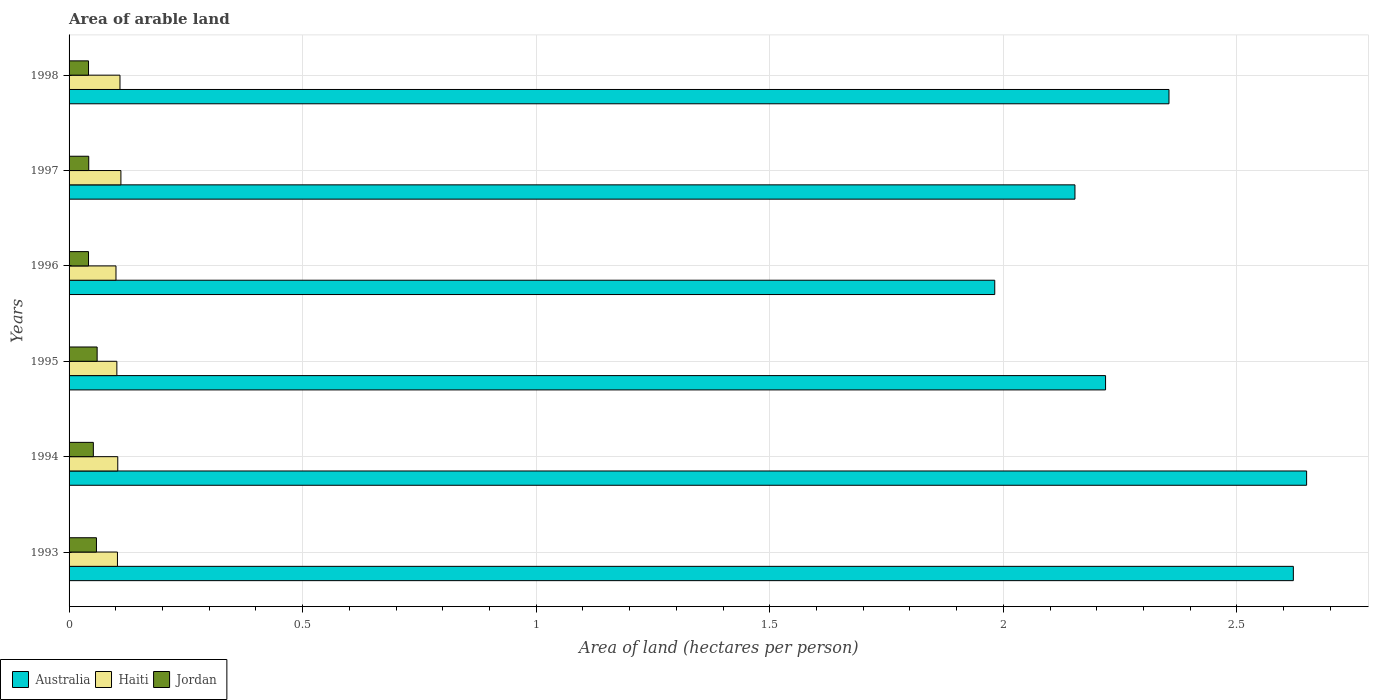Are the number of bars on each tick of the Y-axis equal?
Make the answer very short. Yes. How many bars are there on the 6th tick from the top?
Offer a very short reply. 3. How many bars are there on the 2nd tick from the bottom?
Your answer should be very brief. 3. What is the total arable land in Haiti in 1997?
Offer a terse response. 0.11. Across all years, what is the maximum total arable land in Australia?
Your response must be concise. 2.65. Across all years, what is the minimum total arable land in Haiti?
Offer a very short reply. 0.1. What is the total total arable land in Haiti in the graph?
Give a very brief answer. 0.63. What is the difference between the total arable land in Australia in 1994 and that in 1996?
Provide a succinct answer. 0.67. What is the difference between the total arable land in Australia in 1993 and the total arable land in Haiti in 1996?
Provide a succinct answer. 2.52. What is the average total arable land in Haiti per year?
Your answer should be very brief. 0.11. In the year 1994, what is the difference between the total arable land in Jordan and total arable land in Haiti?
Ensure brevity in your answer.  -0.05. What is the ratio of the total arable land in Haiti in 1993 to that in 1998?
Your response must be concise. 0.95. Is the total arable land in Jordan in 1993 less than that in 1996?
Your answer should be very brief. No. Is the difference between the total arable land in Jordan in 1994 and 1996 greater than the difference between the total arable land in Haiti in 1994 and 1996?
Ensure brevity in your answer.  Yes. What is the difference between the highest and the second highest total arable land in Jordan?
Your response must be concise. 0. What is the difference between the highest and the lowest total arable land in Haiti?
Provide a succinct answer. 0.01. In how many years, is the total arable land in Australia greater than the average total arable land in Australia taken over all years?
Provide a short and direct response. 3. What does the 2nd bar from the top in 1996 represents?
Your answer should be very brief. Haiti. What does the 3rd bar from the bottom in 1994 represents?
Ensure brevity in your answer.  Jordan. Is it the case that in every year, the sum of the total arable land in Australia and total arable land in Jordan is greater than the total arable land in Haiti?
Make the answer very short. Yes. Are all the bars in the graph horizontal?
Provide a succinct answer. Yes. Are the values on the major ticks of X-axis written in scientific E-notation?
Offer a terse response. No. Does the graph contain any zero values?
Offer a terse response. No. Does the graph contain grids?
Ensure brevity in your answer.  Yes. Where does the legend appear in the graph?
Offer a very short reply. Bottom left. How many legend labels are there?
Make the answer very short. 3. What is the title of the graph?
Provide a short and direct response. Area of arable land. Does "Andorra" appear as one of the legend labels in the graph?
Provide a short and direct response. No. What is the label or title of the X-axis?
Give a very brief answer. Area of land (hectares per person). What is the label or title of the Y-axis?
Offer a very short reply. Years. What is the Area of land (hectares per person) of Australia in 1993?
Your response must be concise. 2.62. What is the Area of land (hectares per person) of Haiti in 1993?
Provide a short and direct response. 0.1. What is the Area of land (hectares per person) of Jordan in 1993?
Provide a short and direct response. 0.06. What is the Area of land (hectares per person) in Australia in 1994?
Your response must be concise. 2.65. What is the Area of land (hectares per person) in Haiti in 1994?
Keep it short and to the point. 0.1. What is the Area of land (hectares per person) in Jordan in 1994?
Keep it short and to the point. 0.05. What is the Area of land (hectares per person) of Australia in 1995?
Your response must be concise. 2.22. What is the Area of land (hectares per person) in Haiti in 1995?
Make the answer very short. 0.1. What is the Area of land (hectares per person) in Jordan in 1995?
Offer a terse response. 0.06. What is the Area of land (hectares per person) in Australia in 1996?
Give a very brief answer. 1.98. What is the Area of land (hectares per person) of Haiti in 1996?
Your answer should be compact. 0.1. What is the Area of land (hectares per person) of Jordan in 1996?
Keep it short and to the point. 0.04. What is the Area of land (hectares per person) in Australia in 1997?
Make the answer very short. 2.15. What is the Area of land (hectares per person) in Haiti in 1997?
Keep it short and to the point. 0.11. What is the Area of land (hectares per person) in Jordan in 1997?
Keep it short and to the point. 0.04. What is the Area of land (hectares per person) of Australia in 1998?
Provide a succinct answer. 2.35. What is the Area of land (hectares per person) of Haiti in 1998?
Give a very brief answer. 0.11. What is the Area of land (hectares per person) in Jordan in 1998?
Provide a short and direct response. 0.04. Across all years, what is the maximum Area of land (hectares per person) of Australia?
Offer a terse response. 2.65. Across all years, what is the maximum Area of land (hectares per person) in Haiti?
Your response must be concise. 0.11. Across all years, what is the maximum Area of land (hectares per person) in Jordan?
Your answer should be compact. 0.06. Across all years, what is the minimum Area of land (hectares per person) in Australia?
Offer a very short reply. 1.98. Across all years, what is the minimum Area of land (hectares per person) in Haiti?
Keep it short and to the point. 0.1. Across all years, what is the minimum Area of land (hectares per person) in Jordan?
Keep it short and to the point. 0.04. What is the total Area of land (hectares per person) in Australia in the graph?
Provide a short and direct response. 13.98. What is the total Area of land (hectares per person) in Haiti in the graph?
Keep it short and to the point. 0.63. What is the total Area of land (hectares per person) of Jordan in the graph?
Keep it short and to the point. 0.3. What is the difference between the Area of land (hectares per person) in Australia in 1993 and that in 1994?
Your answer should be compact. -0.03. What is the difference between the Area of land (hectares per person) of Haiti in 1993 and that in 1994?
Provide a succinct answer. -0. What is the difference between the Area of land (hectares per person) in Jordan in 1993 and that in 1994?
Your response must be concise. 0.01. What is the difference between the Area of land (hectares per person) of Australia in 1993 and that in 1995?
Offer a very short reply. 0.4. What is the difference between the Area of land (hectares per person) of Haiti in 1993 and that in 1995?
Your answer should be compact. 0. What is the difference between the Area of land (hectares per person) in Jordan in 1993 and that in 1995?
Provide a succinct answer. -0. What is the difference between the Area of land (hectares per person) in Australia in 1993 and that in 1996?
Your answer should be compact. 0.64. What is the difference between the Area of land (hectares per person) of Haiti in 1993 and that in 1996?
Your response must be concise. 0. What is the difference between the Area of land (hectares per person) of Jordan in 1993 and that in 1996?
Provide a short and direct response. 0.02. What is the difference between the Area of land (hectares per person) in Australia in 1993 and that in 1997?
Offer a terse response. 0.47. What is the difference between the Area of land (hectares per person) in Haiti in 1993 and that in 1997?
Offer a very short reply. -0.01. What is the difference between the Area of land (hectares per person) in Jordan in 1993 and that in 1997?
Your answer should be compact. 0.02. What is the difference between the Area of land (hectares per person) of Australia in 1993 and that in 1998?
Your answer should be very brief. 0.27. What is the difference between the Area of land (hectares per person) in Haiti in 1993 and that in 1998?
Your answer should be compact. -0.01. What is the difference between the Area of land (hectares per person) of Jordan in 1993 and that in 1998?
Your response must be concise. 0.02. What is the difference between the Area of land (hectares per person) of Australia in 1994 and that in 1995?
Offer a very short reply. 0.43. What is the difference between the Area of land (hectares per person) of Haiti in 1994 and that in 1995?
Ensure brevity in your answer.  0. What is the difference between the Area of land (hectares per person) of Jordan in 1994 and that in 1995?
Your answer should be very brief. -0.01. What is the difference between the Area of land (hectares per person) of Australia in 1994 and that in 1996?
Provide a succinct answer. 0.67. What is the difference between the Area of land (hectares per person) in Haiti in 1994 and that in 1996?
Make the answer very short. 0. What is the difference between the Area of land (hectares per person) of Jordan in 1994 and that in 1996?
Ensure brevity in your answer.  0.01. What is the difference between the Area of land (hectares per person) in Australia in 1994 and that in 1997?
Provide a short and direct response. 0.5. What is the difference between the Area of land (hectares per person) of Haiti in 1994 and that in 1997?
Provide a short and direct response. -0.01. What is the difference between the Area of land (hectares per person) of Jordan in 1994 and that in 1997?
Your response must be concise. 0.01. What is the difference between the Area of land (hectares per person) in Australia in 1994 and that in 1998?
Provide a short and direct response. 0.29. What is the difference between the Area of land (hectares per person) of Haiti in 1994 and that in 1998?
Your answer should be very brief. -0. What is the difference between the Area of land (hectares per person) of Jordan in 1994 and that in 1998?
Give a very brief answer. 0.01. What is the difference between the Area of land (hectares per person) in Australia in 1995 and that in 1996?
Give a very brief answer. 0.24. What is the difference between the Area of land (hectares per person) in Haiti in 1995 and that in 1996?
Ensure brevity in your answer.  0. What is the difference between the Area of land (hectares per person) in Jordan in 1995 and that in 1996?
Provide a succinct answer. 0.02. What is the difference between the Area of land (hectares per person) in Australia in 1995 and that in 1997?
Give a very brief answer. 0.07. What is the difference between the Area of land (hectares per person) of Haiti in 1995 and that in 1997?
Provide a short and direct response. -0.01. What is the difference between the Area of land (hectares per person) of Jordan in 1995 and that in 1997?
Offer a very short reply. 0.02. What is the difference between the Area of land (hectares per person) of Australia in 1995 and that in 1998?
Give a very brief answer. -0.14. What is the difference between the Area of land (hectares per person) of Haiti in 1995 and that in 1998?
Offer a terse response. -0.01. What is the difference between the Area of land (hectares per person) in Jordan in 1995 and that in 1998?
Make the answer very short. 0.02. What is the difference between the Area of land (hectares per person) in Australia in 1996 and that in 1997?
Make the answer very short. -0.17. What is the difference between the Area of land (hectares per person) in Haiti in 1996 and that in 1997?
Your answer should be very brief. -0.01. What is the difference between the Area of land (hectares per person) in Jordan in 1996 and that in 1997?
Provide a succinct answer. -0. What is the difference between the Area of land (hectares per person) in Australia in 1996 and that in 1998?
Provide a succinct answer. -0.37. What is the difference between the Area of land (hectares per person) of Haiti in 1996 and that in 1998?
Offer a very short reply. -0.01. What is the difference between the Area of land (hectares per person) in Australia in 1997 and that in 1998?
Your answer should be very brief. -0.2. What is the difference between the Area of land (hectares per person) of Haiti in 1997 and that in 1998?
Your answer should be compact. 0. What is the difference between the Area of land (hectares per person) in Jordan in 1997 and that in 1998?
Keep it short and to the point. 0. What is the difference between the Area of land (hectares per person) in Australia in 1993 and the Area of land (hectares per person) in Haiti in 1994?
Give a very brief answer. 2.52. What is the difference between the Area of land (hectares per person) in Australia in 1993 and the Area of land (hectares per person) in Jordan in 1994?
Your answer should be compact. 2.57. What is the difference between the Area of land (hectares per person) of Haiti in 1993 and the Area of land (hectares per person) of Jordan in 1994?
Offer a very short reply. 0.05. What is the difference between the Area of land (hectares per person) of Australia in 1993 and the Area of land (hectares per person) of Haiti in 1995?
Provide a short and direct response. 2.52. What is the difference between the Area of land (hectares per person) of Australia in 1993 and the Area of land (hectares per person) of Jordan in 1995?
Make the answer very short. 2.56. What is the difference between the Area of land (hectares per person) of Haiti in 1993 and the Area of land (hectares per person) of Jordan in 1995?
Ensure brevity in your answer.  0.04. What is the difference between the Area of land (hectares per person) of Australia in 1993 and the Area of land (hectares per person) of Haiti in 1996?
Keep it short and to the point. 2.52. What is the difference between the Area of land (hectares per person) of Australia in 1993 and the Area of land (hectares per person) of Jordan in 1996?
Offer a very short reply. 2.58. What is the difference between the Area of land (hectares per person) in Haiti in 1993 and the Area of land (hectares per person) in Jordan in 1996?
Offer a terse response. 0.06. What is the difference between the Area of land (hectares per person) in Australia in 1993 and the Area of land (hectares per person) in Haiti in 1997?
Make the answer very short. 2.51. What is the difference between the Area of land (hectares per person) in Australia in 1993 and the Area of land (hectares per person) in Jordan in 1997?
Your response must be concise. 2.58. What is the difference between the Area of land (hectares per person) of Haiti in 1993 and the Area of land (hectares per person) of Jordan in 1997?
Offer a terse response. 0.06. What is the difference between the Area of land (hectares per person) of Australia in 1993 and the Area of land (hectares per person) of Haiti in 1998?
Your answer should be compact. 2.51. What is the difference between the Area of land (hectares per person) of Australia in 1993 and the Area of land (hectares per person) of Jordan in 1998?
Offer a very short reply. 2.58. What is the difference between the Area of land (hectares per person) in Haiti in 1993 and the Area of land (hectares per person) in Jordan in 1998?
Keep it short and to the point. 0.06. What is the difference between the Area of land (hectares per person) in Australia in 1994 and the Area of land (hectares per person) in Haiti in 1995?
Ensure brevity in your answer.  2.55. What is the difference between the Area of land (hectares per person) of Australia in 1994 and the Area of land (hectares per person) of Jordan in 1995?
Your response must be concise. 2.59. What is the difference between the Area of land (hectares per person) of Haiti in 1994 and the Area of land (hectares per person) of Jordan in 1995?
Provide a succinct answer. 0.04. What is the difference between the Area of land (hectares per person) in Australia in 1994 and the Area of land (hectares per person) in Haiti in 1996?
Ensure brevity in your answer.  2.55. What is the difference between the Area of land (hectares per person) of Australia in 1994 and the Area of land (hectares per person) of Jordan in 1996?
Make the answer very short. 2.61. What is the difference between the Area of land (hectares per person) in Haiti in 1994 and the Area of land (hectares per person) in Jordan in 1996?
Ensure brevity in your answer.  0.06. What is the difference between the Area of land (hectares per person) in Australia in 1994 and the Area of land (hectares per person) in Haiti in 1997?
Your response must be concise. 2.54. What is the difference between the Area of land (hectares per person) in Australia in 1994 and the Area of land (hectares per person) in Jordan in 1997?
Ensure brevity in your answer.  2.61. What is the difference between the Area of land (hectares per person) in Haiti in 1994 and the Area of land (hectares per person) in Jordan in 1997?
Give a very brief answer. 0.06. What is the difference between the Area of land (hectares per person) in Australia in 1994 and the Area of land (hectares per person) in Haiti in 1998?
Your answer should be compact. 2.54. What is the difference between the Area of land (hectares per person) in Australia in 1994 and the Area of land (hectares per person) in Jordan in 1998?
Make the answer very short. 2.61. What is the difference between the Area of land (hectares per person) in Haiti in 1994 and the Area of land (hectares per person) in Jordan in 1998?
Provide a short and direct response. 0.06. What is the difference between the Area of land (hectares per person) in Australia in 1995 and the Area of land (hectares per person) in Haiti in 1996?
Keep it short and to the point. 2.12. What is the difference between the Area of land (hectares per person) of Australia in 1995 and the Area of land (hectares per person) of Jordan in 1996?
Your response must be concise. 2.18. What is the difference between the Area of land (hectares per person) of Haiti in 1995 and the Area of land (hectares per person) of Jordan in 1996?
Your answer should be compact. 0.06. What is the difference between the Area of land (hectares per person) in Australia in 1995 and the Area of land (hectares per person) in Haiti in 1997?
Your response must be concise. 2.11. What is the difference between the Area of land (hectares per person) in Australia in 1995 and the Area of land (hectares per person) in Jordan in 1997?
Provide a succinct answer. 2.18. What is the difference between the Area of land (hectares per person) in Haiti in 1995 and the Area of land (hectares per person) in Jordan in 1997?
Make the answer very short. 0.06. What is the difference between the Area of land (hectares per person) of Australia in 1995 and the Area of land (hectares per person) of Haiti in 1998?
Offer a very short reply. 2.11. What is the difference between the Area of land (hectares per person) in Australia in 1995 and the Area of land (hectares per person) in Jordan in 1998?
Provide a short and direct response. 2.18. What is the difference between the Area of land (hectares per person) in Haiti in 1995 and the Area of land (hectares per person) in Jordan in 1998?
Offer a very short reply. 0.06. What is the difference between the Area of land (hectares per person) in Australia in 1996 and the Area of land (hectares per person) in Haiti in 1997?
Ensure brevity in your answer.  1.87. What is the difference between the Area of land (hectares per person) of Australia in 1996 and the Area of land (hectares per person) of Jordan in 1997?
Make the answer very short. 1.94. What is the difference between the Area of land (hectares per person) in Haiti in 1996 and the Area of land (hectares per person) in Jordan in 1997?
Provide a succinct answer. 0.06. What is the difference between the Area of land (hectares per person) in Australia in 1996 and the Area of land (hectares per person) in Haiti in 1998?
Give a very brief answer. 1.87. What is the difference between the Area of land (hectares per person) of Australia in 1996 and the Area of land (hectares per person) of Jordan in 1998?
Provide a succinct answer. 1.94. What is the difference between the Area of land (hectares per person) of Haiti in 1996 and the Area of land (hectares per person) of Jordan in 1998?
Keep it short and to the point. 0.06. What is the difference between the Area of land (hectares per person) of Australia in 1997 and the Area of land (hectares per person) of Haiti in 1998?
Offer a very short reply. 2.04. What is the difference between the Area of land (hectares per person) in Australia in 1997 and the Area of land (hectares per person) in Jordan in 1998?
Your response must be concise. 2.11. What is the difference between the Area of land (hectares per person) in Haiti in 1997 and the Area of land (hectares per person) in Jordan in 1998?
Provide a succinct answer. 0.07. What is the average Area of land (hectares per person) in Australia per year?
Make the answer very short. 2.33. What is the average Area of land (hectares per person) in Haiti per year?
Your response must be concise. 0.11. What is the average Area of land (hectares per person) of Jordan per year?
Give a very brief answer. 0.05. In the year 1993, what is the difference between the Area of land (hectares per person) in Australia and Area of land (hectares per person) in Haiti?
Give a very brief answer. 2.52. In the year 1993, what is the difference between the Area of land (hectares per person) in Australia and Area of land (hectares per person) in Jordan?
Offer a very short reply. 2.56. In the year 1993, what is the difference between the Area of land (hectares per person) of Haiti and Area of land (hectares per person) of Jordan?
Your answer should be compact. 0.04. In the year 1994, what is the difference between the Area of land (hectares per person) of Australia and Area of land (hectares per person) of Haiti?
Your response must be concise. 2.54. In the year 1994, what is the difference between the Area of land (hectares per person) in Australia and Area of land (hectares per person) in Jordan?
Your response must be concise. 2.6. In the year 1994, what is the difference between the Area of land (hectares per person) of Haiti and Area of land (hectares per person) of Jordan?
Provide a short and direct response. 0.05. In the year 1995, what is the difference between the Area of land (hectares per person) in Australia and Area of land (hectares per person) in Haiti?
Provide a short and direct response. 2.12. In the year 1995, what is the difference between the Area of land (hectares per person) of Australia and Area of land (hectares per person) of Jordan?
Provide a succinct answer. 2.16. In the year 1995, what is the difference between the Area of land (hectares per person) of Haiti and Area of land (hectares per person) of Jordan?
Your answer should be very brief. 0.04. In the year 1996, what is the difference between the Area of land (hectares per person) in Australia and Area of land (hectares per person) in Haiti?
Your response must be concise. 1.88. In the year 1996, what is the difference between the Area of land (hectares per person) in Australia and Area of land (hectares per person) in Jordan?
Give a very brief answer. 1.94. In the year 1996, what is the difference between the Area of land (hectares per person) in Haiti and Area of land (hectares per person) in Jordan?
Your answer should be very brief. 0.06. In the year 1997, what is the difference between the Area of land (hectares per person) of Australia and Area of land (hectares per person) of Haiti?
Your answer should be very brief. 2.04. In the year 1997, what is the difference between the Area of land (hectares per person) in Australia and Area of land (hectares per person) in Jordan?
Provide a short and direct response. 2.11. In the year 1997, what is the difference between the Area of land (hectares per person) in Haiti and Area of land (hectares per person) in Jordan?
Make the answer very short. 0.07. In the year 1998, what is the difference between the Area of land (hectares per person) in Australia and Area of land (hectares per person) in Haiti?
Offer a terse response. 2.25. In the year 1998, what is the difference between the Area of land (hectares per person) of Australia and Area of land (hectares per person) of Jordan?
Make the answer very short. 2.31. In the year 1998, what is the difference between the Area of land (hectares per person) of Haiti and Area of land (hectares per person) of Jordan?
Ensure brevity in your answer.  0.07. What is the ratio of the Area of land (hectares per person) of Australia in 1993 to that in 1994?
Make the answer very short. 0.99. What is the ratio of the Area of land (hectares per person) in Jordan in 1993 to that in 1994?
Provide a succinct answer. 1.13. What is the ratio of the Area of land (hectares per person) in Australia in 1993 to that in 1995?
Keep it short and to the point. 1.18. What is the ratio of the Area of land (hectares per person) of Haiti in 1993 to that in 1995?
Offer a very short reply. 1.01. What is the ratio of the Area of land (hectares per person) of Jordan in 1993 to that in 1995?
Offer a terse response. 0.98. What is the ratio of the Area of land (hectares per person) in Australia in 1993 to that in 1996?
Your response must be concise. 1.32. What is the ratio of the Area of land (hectares per person) in Haiti in 1993 to that in 1996?
Provide a succinct answer. 1.03. What is the ratio of the Area of land (hectares per person) of Jordan in 1993 to that in 1996?
Offer a terse response. 1.41. What is the ratio of the Area of land (hectares per person) in Australia in 1993 to that in 1997?
Keep it short and to the point. 1.22. What is the ratio of the Area of land (hectares per person) in Haiti in 1993 to that in 1997?
Provide a succinct answer. 0.93. What is the ratio of the Area of land (hectares per person) of Jordan in 1993 to that in 1997?
Offer a very short reply. 1.39. What is the ratio of the Area of land (hectares per person) of Australia in 1993 to that in 1998?
Keep it short and to the point. 1.11. What is the ratio of the Area of land (hectares per person) in Haiti in 1993 to that in 1998?
Make the answer very short. 0.95. What is the ratio of the Area of land (hectares per person) in Jordan in 1993 to that in 1998?
Offer a terse response. 1.41. What is the ratio of the Area of land (hectares per person) in Australia in 1994 to that in 1995?
Give a very brief answer. 1.19. What is the ratio of the Area of land (hectares per person) of Haiti in 1994 to that in 1995?
Make the answer very short. 1.02. What is the ratio of the Area of land (hectares per person) in Jordan in 1994 to that in 1995?
Your answer should be compact. 0.86. What is the ratio of the Area of land (hectares per person) of Australia in 1994 to that in 1996?
Offer a terse response. 1.34. What is the ratio of the Area of land (hectares per person) in Haiti in 1994 to that in 1996?
Offer a very short reply. 1.04. What is the ratio of the Area of land (hectares per person) of Jordan in 1994 to that in 1996?
Offer a very short reply. 1.25. What is the ratio of the Area of land (hectares per person) of Australia in 1994 to that in 1997?
Ensure brevity in your answer.  1.23. What is the ratio of the Area of land (hectares per person) of Haiti in 1994 to that in 1997?
Your answer should be very brief. 0.94. What is the ratio of the Area of land (hectares per person) of Jordan in 1994 to that in 1997?
Your response must be concise. 1.23. What is the ratio of the Area of land (hectares per person) of Australia in 1994 to that in 1998?
Offer a very short reply. 1.13. What is the ratio of the Area of land (hectares per person) of Haiti in 1994 to that in 1998?
Offer a very short reply. 0.96. What is the ratio of the Area of land (hectares per person) in Jordan in 1994 to that in 1998?
Keep it short and to the point. 1.25. What is the ratio of the Area of land (hectares per person) of Australia in 1995 to that in 1996?
Offer a very short reply. 1.12. What is the ratio of the Area of land (hectares per person) of Haiti in 1995 to that in 1996?
Keep it short and to the point. 1.02. What is the ratio of the Area of land (hectares per person) in Jordan in 1995 to that in 1996?
Provide a short and direct response. 1.44. What is the ratio of the Area of land (hectares per person) of Australia in 1995 to that in 1997?
Your answer should be compact. 1.03. What is the ratio of the Area of land (hectares per person) in Haiti in 1995 to that in 1997?
Your response must be concise. 0.92. What is the ratio of the Area of land (hectares per person) in Jordan in 1995 to that in 1997?
Your response must be concise. 1.43. What is the ratio of the Area of land (hectares per person) of Australia in 1995 to that in 1998?
Provide a short and direct response. 0.94. What is the ratio of the Area of land (hectares per person) of Haiti in 1995 to that in 1998?
Give a very brief answer. 0.94. What is the ratio of the Area of land (hectares per person) in Jordan in 1995 to that in 1998?
Offer a terse response. 1.44. What is the ratio of the Area of land (hectares per person) of Australia in 1996 to that in 1997?
Your answer should be very brief. 0.92. What is the ratio of the Area of land (hectares per person) in Haiti in 1996 to that in 1997?
Offer a terse response. 0.91. What is the ratio of the Area of land (hectares per person) of Australia in 1996 to that in 1998?
Your answer should be very brief. 0.84. What is the ratio of the Area of land (hectares per person) of Haiti in 1996 to that in 1998?
Provide a short and direct response. 0.92. What is the ratio of the Area of land (hectares per person) of Australia in 1997 to that in 1998?
Provide a succinct answer. 0.91. What is the ratio of the Area of land (hectares per person) of Haiti in 1997 to that in 1998?
Provide a succinct answer. 1.02. What is the ratio of the Area of land (hectares per person) in Jordan in 1997 to that in 1998?
Offer a very short reply. 1.01. What is the difference between the highest and the second highest Area of land (hectares per person) in Australia?
Your answer should be very brief. 0.03. What is the difference between the highest and the second highest Area of land (hectares per person) in Haiti?
Make the answer very short. 0. What is the difference between the highest and the second highest Area of land (hectares per person) of Jordan?
Offer a very short reply. 0. What is the difference between the highest and the lowest Area of land (hectares per person) of Australia?
Provide a short and direct response. 0.67. What is the difference between the highest and the lowest Area of land (hectares per person) of Haiti?
Your answer should be compact. 0.01. What is the difference between the highest and the lowest Area of land (hectares per person) of Jordan?
Give a very brief answer. 0.02. 